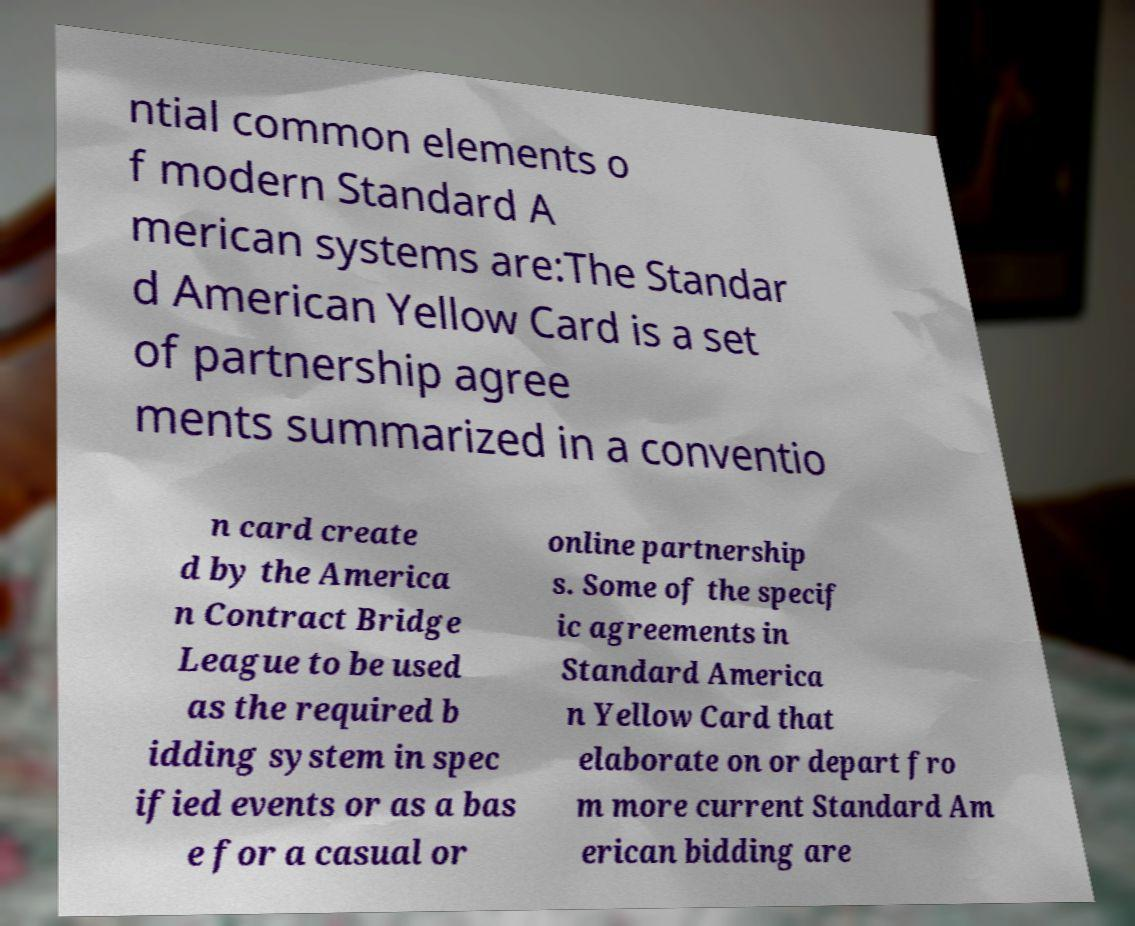Please identify and transcribe the text found in this image. ntial common elements o f modern Standard A merican systems are:The Standar d American Yellow Card is a set of partnership agree ments summarized in a conventio n card create d by the America n Contract Bridge League to be used as the required b idding system in spec ified events or as a bas e for a casual or online partnership s. Some of the specif ic agreements in Standard America n Yellow Card that elaborate on or depart fro m more current Standard Am erican bidding are 